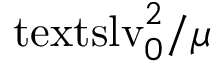Convert formula to latex. <formula><loc_0><loc_0><loc_500><loc_500>{ \ t e x t s l { v } _ { 0 } } ^ { 2 } / \mu</formula> 